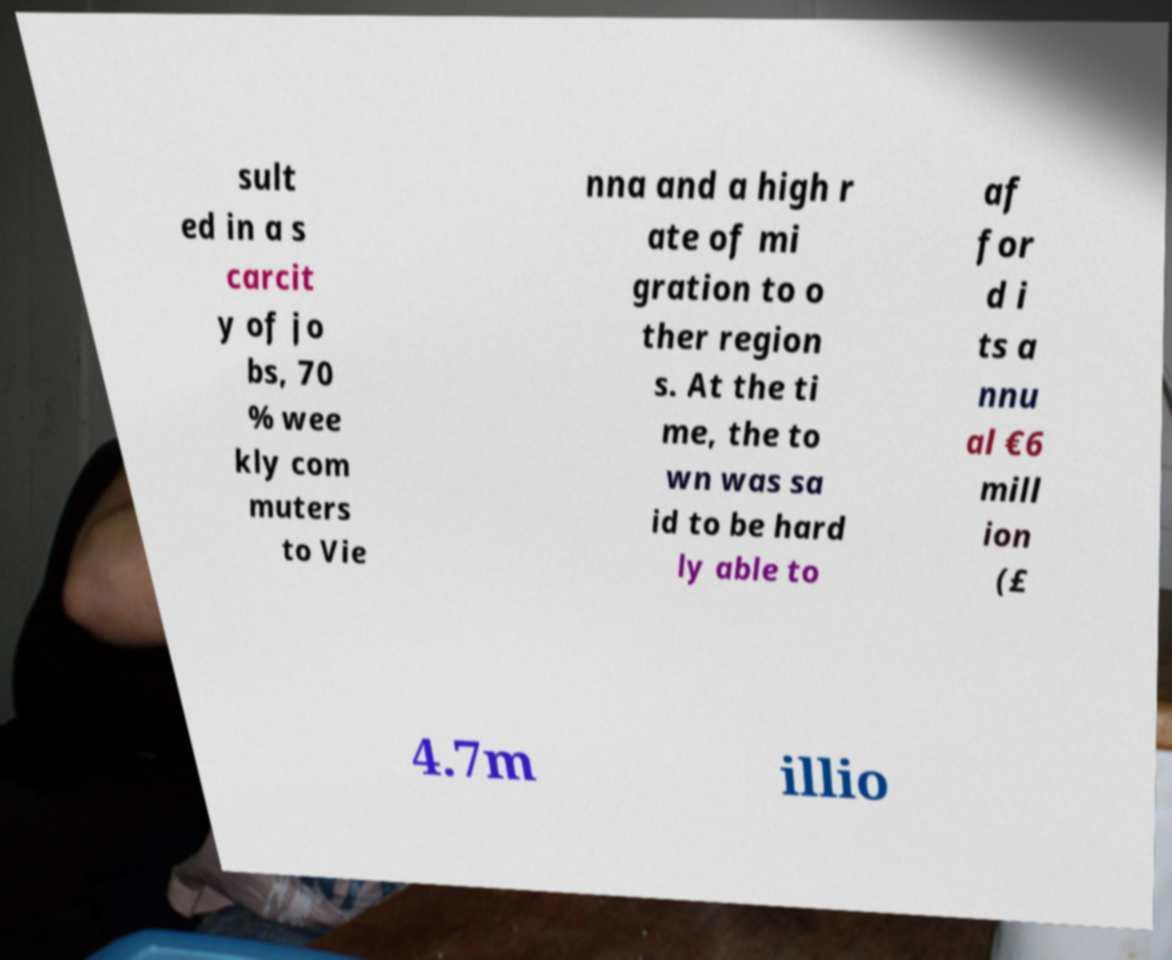I need the written content from this picture converted into text. Can you do that? sult ed in a s carcit y of jo bs, 70 % wee kly com muters to Vie nna and a high r ate of mi gration to o ther region s. At the ti me, the to wn was sa id to be hard ly able to af for d i ts a nnu al €6 mill ion (£ 4.7m illio 